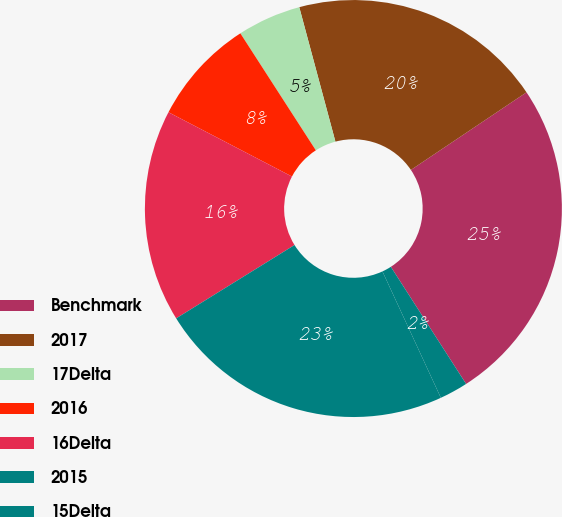Convert chart. <chart><loc_0><loc_0><loc_500><loc_500><pie_chart><fcel>Benchmark<fcel>2017<fcel>17Delta<fcel>2016<fcel>16Delta<fcel>2015<fcel>15Delta<nl><fcel>25.32%<fcel>19.77%<fcel>4.94%<fcel>8.24%<fcel>16.47%<fcel>23.06%<fcel>2.2%<nl></chart> 